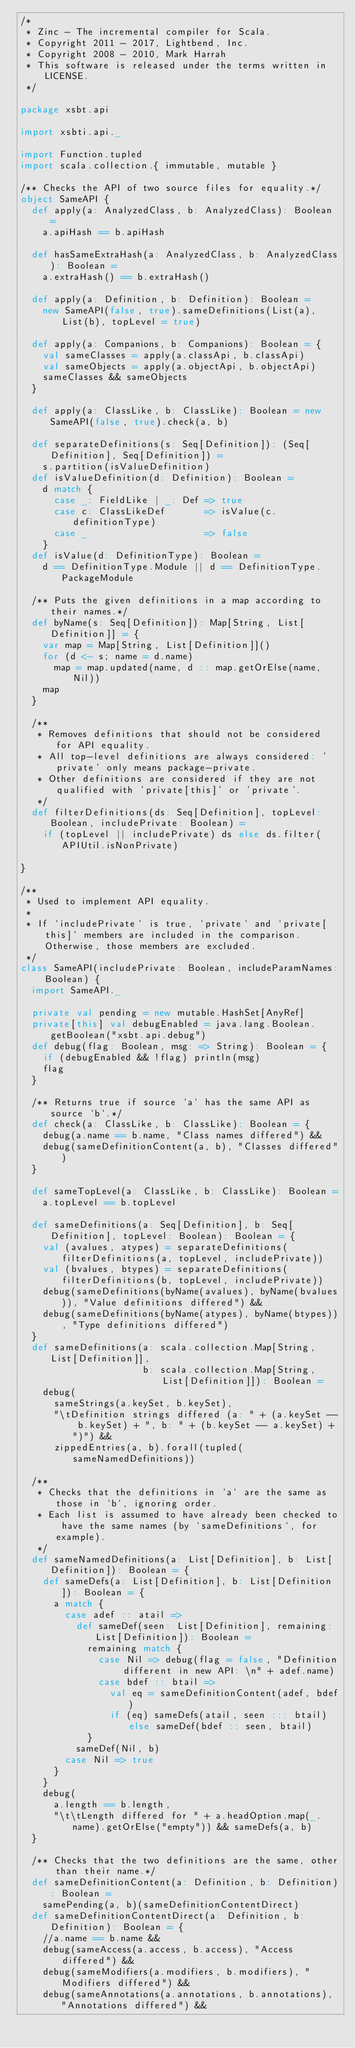Convert code to text. <code><loc_0><loc_0><loc_500><loc_500><_Scala_>/*
 * Zinc - The incremental compiler for Scala.
 * Copyright 2011 - 2017, Lightbend, Inc.
 * Copyright 2008 - 2010, Mark Harrah
 * This software is released under the terms written in LICENSE.
 */

package xsbt.api

import xsbti.api._

import Function.tupled
import scala.collection.{ immutable, mutable }

/** Checks the API of two source files for equality.*/
object SameAPI {
  def apply(a: AnalyzedClass, b: AnalyzedClass): Boolean =
    a.apiHash == b.apiHash

  def hasSameExtraHash(a: AnalyzedClass, b: AnalyzedClass): Boolean =
    a.extraHash() == b.extraHash()

  def apply(a: Definition, b: Definition): Boolean =
    new SameAPI(false, true).sameDefinitions(List(a), List(b), topLevel = true)

  def apply(a: Companions, b: Companions): Boolean = {
    val sameClasses = apply(a.classApi, b.classApi)
    val sameObjects = apply(a.objectApi, b.objectApi)
    sameClasses && sameObjects
  }

  def apply(a: ClassLike, b: ClassLike): Boolean = new SameAPI(false, true).check(a, b)

  def separateDefinitions(s: Seq[Definition]): (Seq[Definition], Seq[Definition]) =
    s.partition(isValueDefinition)
  def isValueDefinition(d: Definition): Boolean =
    d match {
      case _: FieldLike | _: Def => true
      case c: ClassLikeDef       => isValue(c.definitionType)
      case _                     => false
    }
  def isValue(d: DefinitionType): Boolean =
    d == DefinitionType.Module || d == DefinitionType.PackageModule

  /** Puts the given definitions in a map according to their names.*/
  def byName(s: Seq[Definition]): Map[String, List[Definition]] = {
    var map = Map[String, List[Definition]]()
    for (d <- s; name = d.name)
      map = map.updated(name, d :: map.getOrElse(name, Nil))
    map
  }

  /**
   * Removes definitions that should not be considered for API equality.
   * All top-level definitions are always considered: 'private' only means package-private.
   * Other definitions are considered if they are not qualified with 'private[this]' or 'private'.
   */
  def filterDefinitions(ds: Seq[Definition], topLevel: Boolean, includePrivate: Boolean) =
    if (topLevel || includePrivate) ds else ds.filter(APIUtil.isNonPrivate)

}

/**
 * Used to implement API equality.
 *
 * If `includePrivate` is true, `private` and `private[this]` members are included in the comparison.  Otherwise, those members are excluded.
 */
class SameAPI(includePrivate: Boolean, includeParamNames: Boolean) {
  import SameAPI._

  private val pending = new mutable.HashSet[AnyRef]
  private[this] val debugEnabled = java.lang.Boolean.getBoolean("xsbt.api.debug")
  def debug(flag: Boolean, msg: => String): Boolean = {
    if (debugEnabled && !flag) println(msg)
    flag
  }

  /** Returns true if source `a` has the same API as source `b`.*/
  def check(a: ClassLike, b: ClassLike): Boolean = {
    debug(a.name == b.name, "Class names differed") &&
    debug(sameDefinitionContent(a, b), "Classes differed")
  }

  def sameTopLevel(a: ClassLike, b: ClassLike): Boolean =
    a.topLevel == b.topLevel

  def sameDefinitions(a: Seq[Definition], b: Seq[Definition], topLevel: Boolean): Boolean = {
    val (avalues, atypes) = separateDefinitions(filterDefinitions(a, topLevel, includePrivate))
    val (bvalues, btypes) = separateDefinitions(filterDefinitions(b, topLevel, includePrivate))
    debug(sameDefinitions(byName(avalues), byName(bvalues)), "Value definitions differed") &&
    debug(sameDefinitions(byName(atypes), byName(btypes)), "Type definitions differed")
  }
  def sameDefinitions(a: scala.collection.Map[String, List[Definition]],
                      b: scala.collection.Map[String, List[Definition]]): Boolean =
    debug(
      sameStrings(a.keySet, b.keySet),
      "\tDefinition strings differed (a: " + (a.keySet -- b.keySet) + ", b: " + (b.keySet -- a.keySet) + ")") &&
      zippedEntries(a, b).forall(tupled(sameNamedDefinitions))

  /**
   * Checks that the definitions in `a` are the same as those in `b`, ignoring order.
   * Each list is assumed to have already been checked to have the same names (by `sameDefinitions`, for example).
   */
  def sameNamedDefinitions(a: List[Definition], b: List[Definition]): Boolean = {
    def sameDefs(a: List[Definition], b: List[Definition]): Boolean = {
      a match {
        case adef :: atail =>
          def sameDef(seen: List[Definition], remaining: List[Definition]): Boolean =
            remaining match {
              case Nil => debug(flag = false, "Definition different in new API: \n" + adef.name)
              case bdef :: btail =>
                val eq = sameDefinitionContent(adef, bdef)
                if (eq) sameDefs(atail, seen ::: btail) else sameDef(bdef :: seen, btail)
            }
          sameDef(Nil, b)
        case Nil => true
      }
    }
    debug(
      a.length == b.length,
      "\t\tLength differed for " + a.headOption.map(_.name).getOrElse("empty")) && sameDefs(a, b)
  }

  /** Checks that the two definitions are the same, other than their name.*/
  def sameDefinitionContent(a: Definition, b: Definition): Boolean =
    samePending(a, b)(sameDefinitionContentDirect)
  def sameDefinitionContentDirect(a: Definition, b: Definition): Boolean = {
    //a.name == b.name &&
    debug(sameAccess(a.access, b.access), "Access differed") &&
    debug(sameModifiers(a.modifiers, b.modifiers), "Modifiers differed") &&
    debug(sameAnnotations(a.annotations, b.annotations), "Annotations differed") &&</code> 